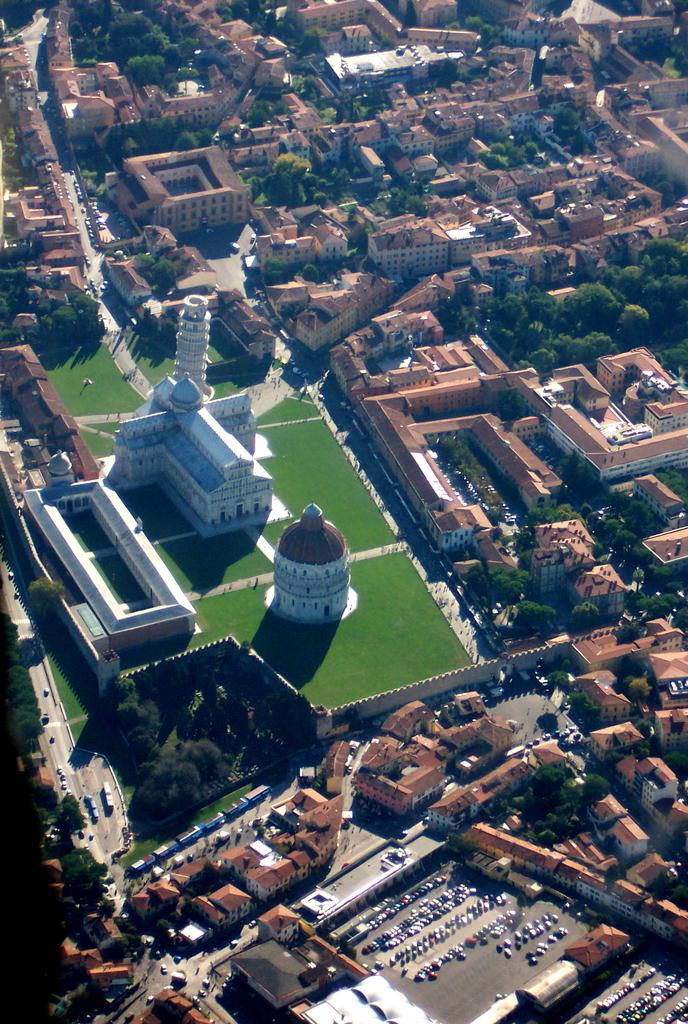What type of view is shown in the image? The image is an aerial view of a city. What structures can be seen in the city? There are many buildings and houses in the city. How are people able to travel within the city? There are roads in the city for transportation. Are there any green spaces in the city? Yes, there is a garden in the city. What type of vegetation is present in the city? There are a lot of trees in the city. What type of behavior can be observed in the duck in the image? There is no duck present in the image; it is an aerial view of a city with no animals visible. 